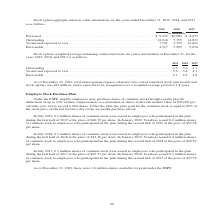According to Teradyne's financial document, What was the total unrecognized expense related to non-vested restricted stock unit awards and stock options in 2019? According to the financial document, $45 million. The relevant text states: "restricted stock unit awards and stock options was $45 million, and is expected to be recognized over a weighted average period of 1.8 years...." Also, How long is the total unrecognized expense related to non-vested restricted stock unit awards and stock options expected to be recognized? over a weighted average period of 1.8 years.. The document states: "was $45 million, and is expected to be recognized over a weighted average period of 1.8 years...." Also, In which years is information on Stock options weighted average remaining contractual terms provided? The document contains multiple relevant values: 2019, 2018, 2017. From the document: "2019 2018 2017 2019 2018 2017 2019 2018 2017..." Additionally, In which year was the Exercisable amount the largest? According to the financial document, 2017. The relevant text states: "2019 2018 2017..." Also, can you calculate: What was the change in the Exercisable amount in 2019 from 2018? Based on the calculation: 2.1-2.4, the result is -0.3. This is based on the information: "expected to vest . 5.0 3.6 4.1 Exercisable . 2.1 2.4 2.8 and expected to vest . 5.0 3.6 4.1 Exercisable . 2.1 2.4 2.8..." The key data points involved are: 2.1, 2.4. Also, can you calculate: What was the percentage change in the Exercisable amount in 2019 from 2018? To answer this question, I need to perform calculations using the financial data. The calculation is: (2.1-2.4)/2.4, which equals -12.5 (percentage). This is based on the information: "expected to vest . 5.0 3.6 4.1 Exercisable . 2.1 2.4 2.8 and expected to vest . 5.0 3.6 4.1 Exercisable . 2.1 2.4 2.8..." The key data points involved are: 2.1, 2.4. 